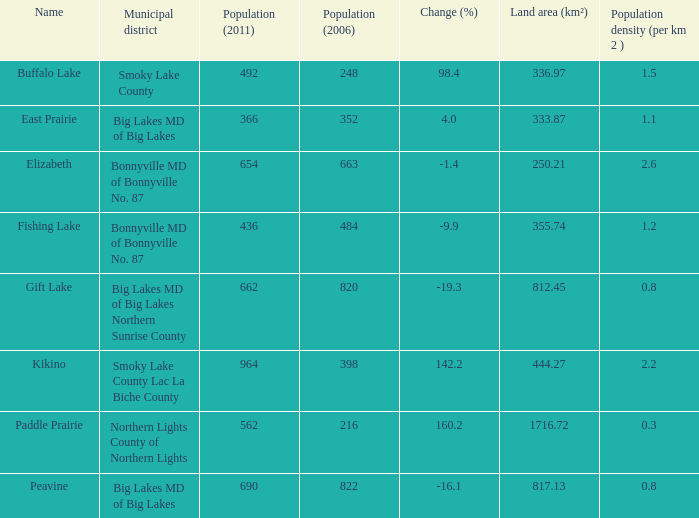What is the population per km in Smoky Lake County? 1.5. 